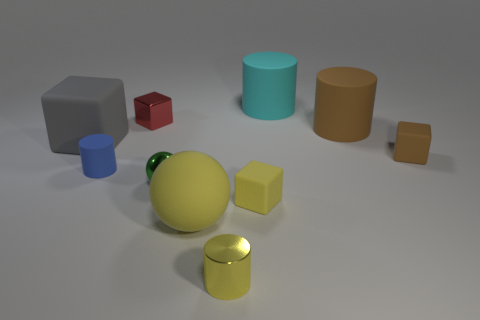Subtract 1 cubes. How many cubes are left? 3 Subtract all blocks. How many objects are left? 6 Add 9 tiny shiny spheres. How many tiny shiny spheres exist? 10 Subtract 0 green cylinders. How many objects are left? 10 Subtract all large purple shiny blocks. Subtract all tiny yellow rubber things. How many objects are left? 9 Add 2 big rubber balls. How many big rubber balls are left? 3 